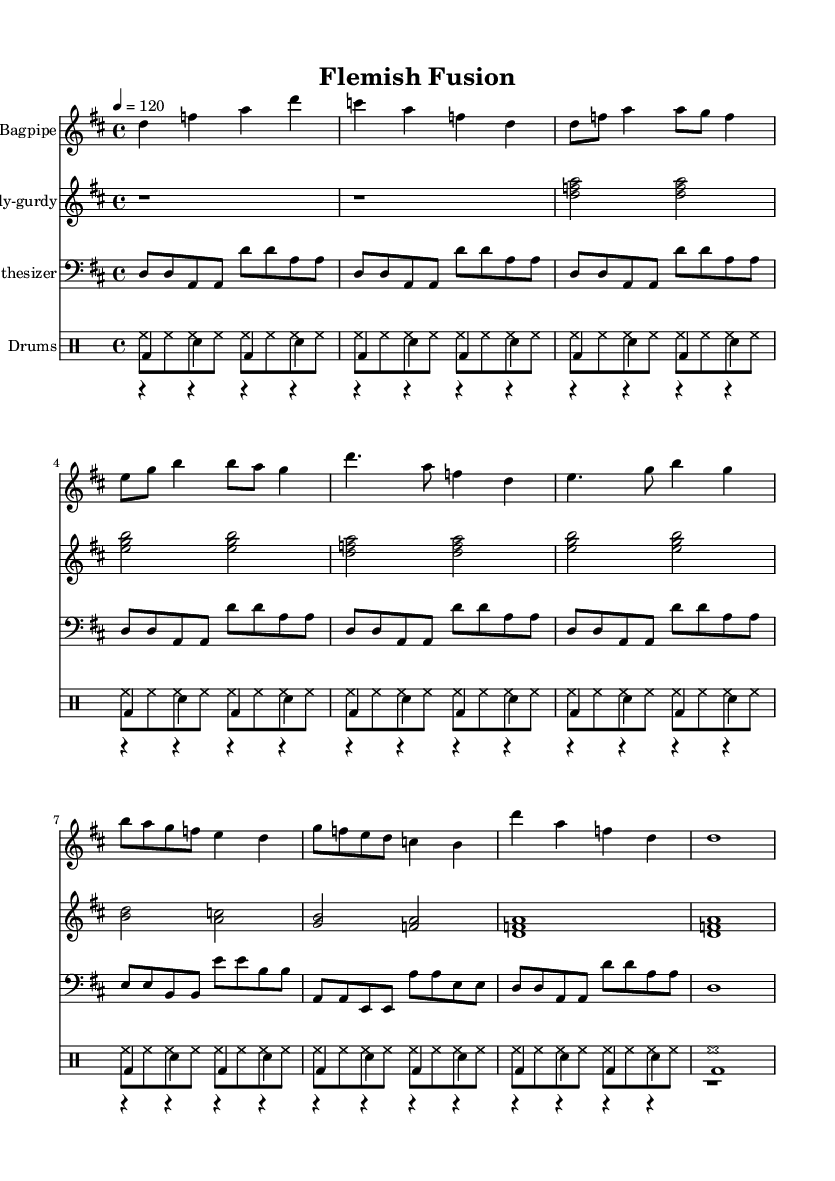What is the key signature of this music? The key signature is D major, which has two sharps (F# and C#). This is determined by analyzing the key signature notation at the beginning of the score.
Answer: D major What is the time signature of this piece? The time signature is 4/4, which means there are four beats in each measure and the quarter note gets one beat. This is found at the beginning of the score where the time signature is notated.
Answer: 4/4 What is the tempo marking for this music? The tempo marking is 120 beats per minute, indicated by the tempo indication provided in the global definition. The tempo relates to how quickly the music is intended to be played.
Answer: 120 Which traditional instrument is featured prominently in this score? The traditional instrument featured primarily is the Bagpipe, as it is written as the first staff in the score, which showcases its distinct melody lines.
Answer: Bagpipe How many measures are in the piece? There are 18 measures in total, which can be confirmed by counting the number of measure bars across all staves in the score.
Answer: 18 What type of drums are used in this arrangement? The drums used are bass drum, snare drum, and hi-hat, as indicated by the specific rhythmic patterns written under the DrumStaff. This showcases a blend of traditional and modern elements in the rhythm section.
Answer: Bass, snare, hi-hat How do the synthesizer rhythms correspond to the traditional instruments? The synthesizer plays a repetitive, steady rhythm that complements the more intricate melodies of the Bagpipe and Hurdy-gurdy, providing a modern electronic layer that enhances the fusion aspect of the piece. This reasoning is based on the aligned patterns between the synthesizer and the other instruments.
Answer: Steady complementary rhythm 